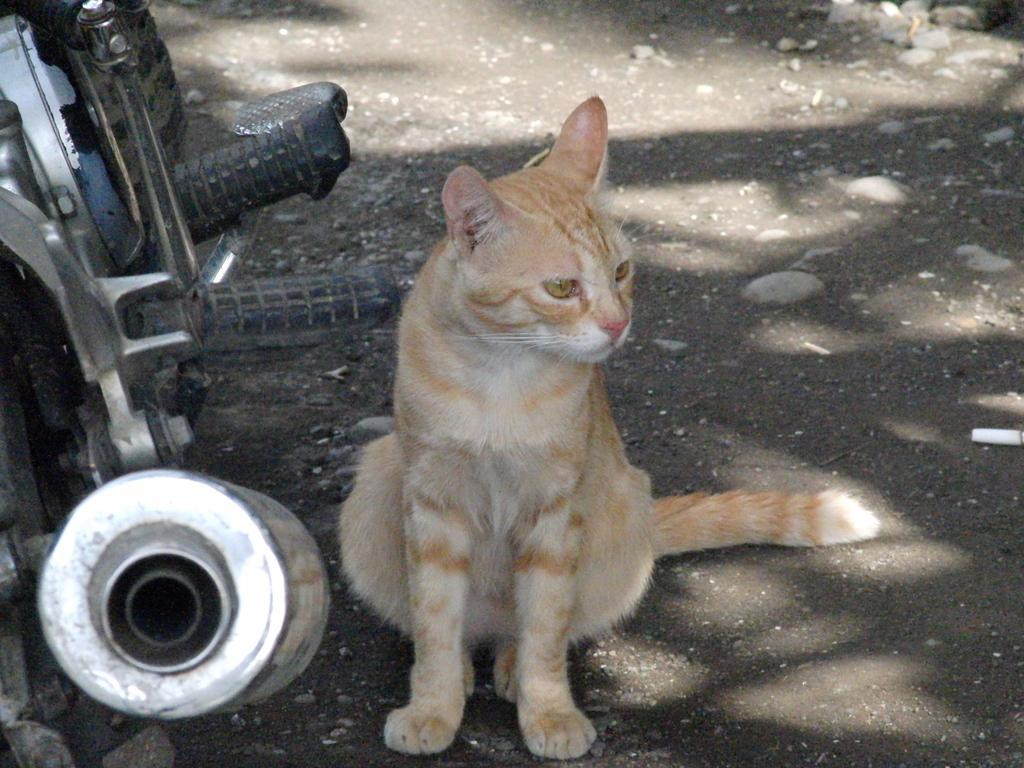What type of animal is in the image? There is a brown cat in the image. Where is the cat located? The cat is on the ground. What else can be seen on the left side of the image? There is a bike on the left side of the image. What type of cloud can be seen in the image? There is no cloud present in the image; it features a brown cat on the ground and a bike on the left side. 